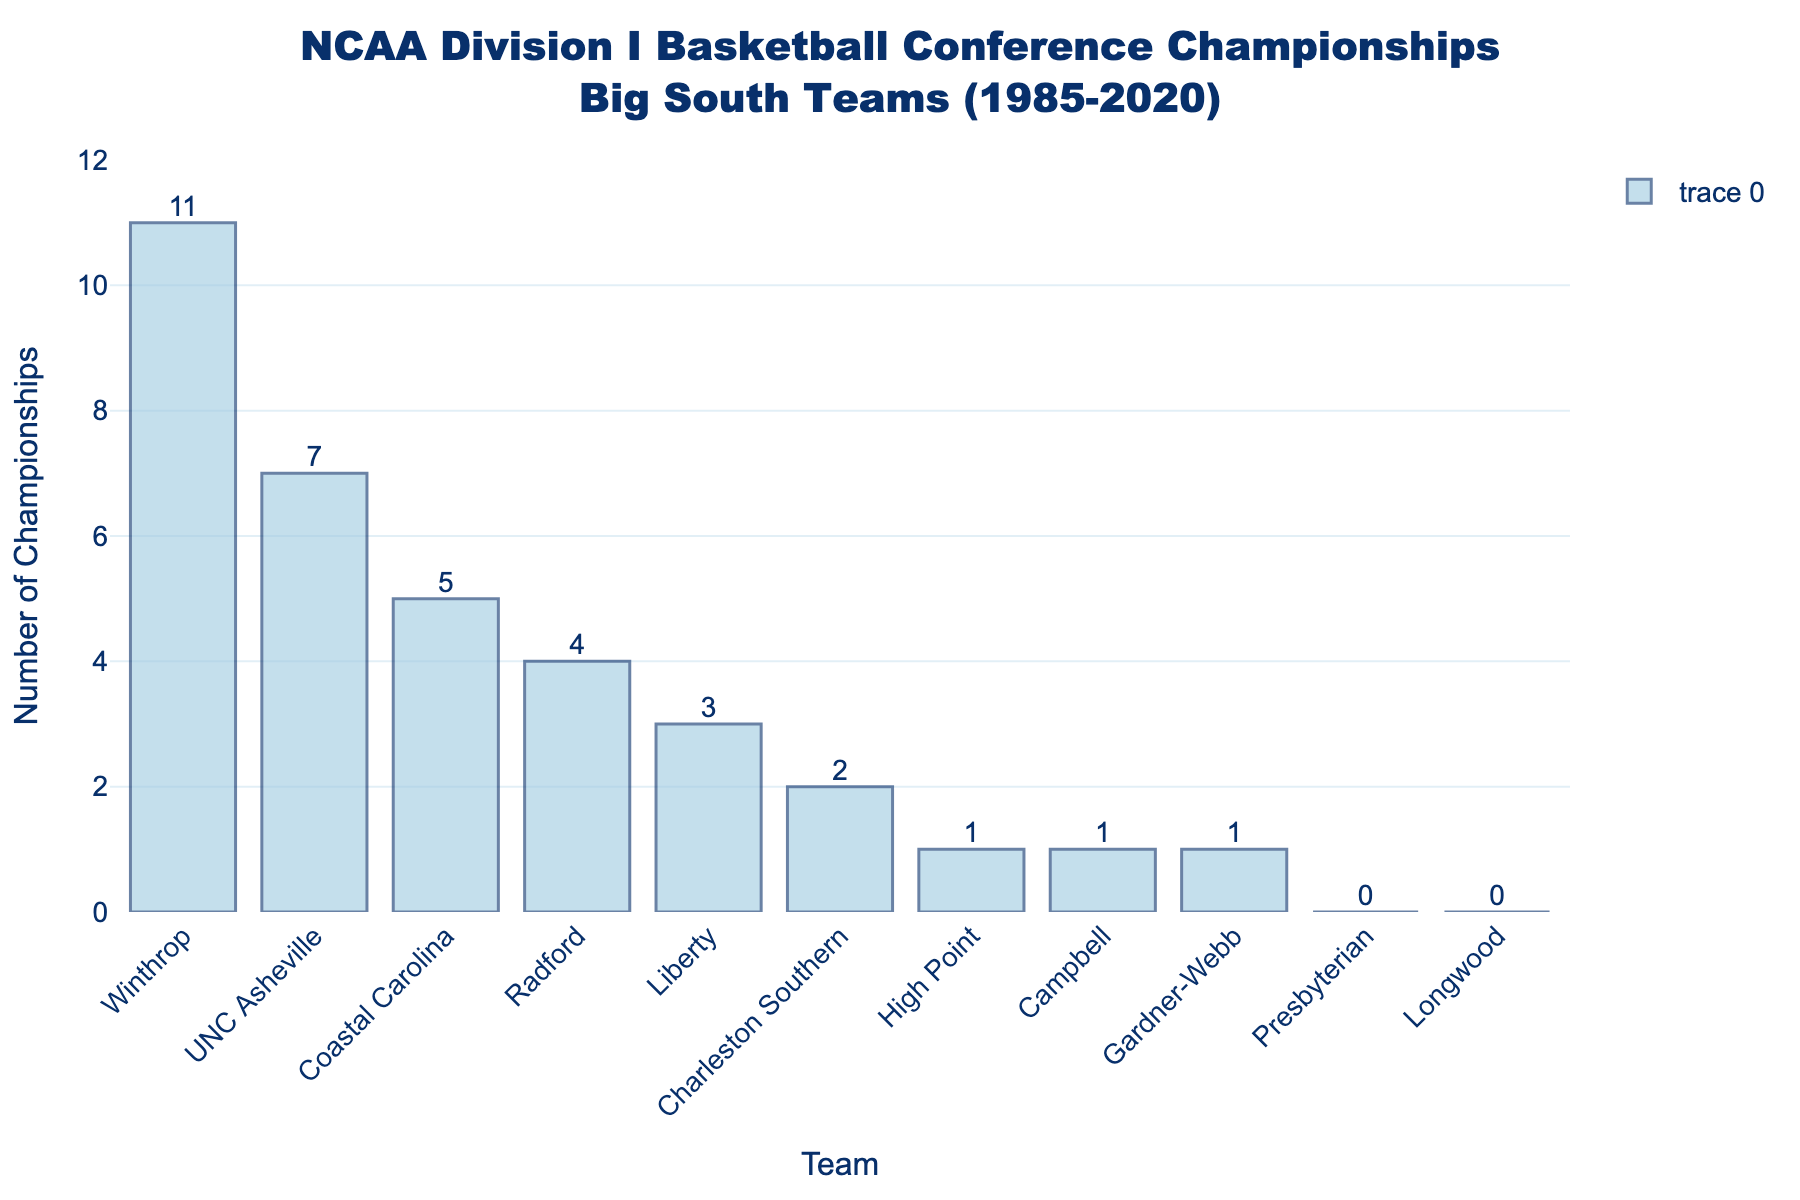What team has won the most championships? The bar representing Winthrop is the tallest in the chart, indicating they have the highest number of championships won. This is confirmed by the label on top of the bar showing 11 championships.
Answer: Winthrop How many teams have won exactly one championship? The bars representing High Point, Campbell, and Gardner-Webb each have a height corresponding to one championship.
Answer: 3 Which team has won more championships, Radford or Coastal Carolina? By comparing the heights of the bars for Radford and Coastal Carolina, it's clear Coastal Carolina's bar is taller, indicating more championships. Specifically, Coastal Carolina has 5 while Radford has 4.
Answer: Coastal Carolina What's the total number of championships won by all teams combined? By summing up all the numbers on top of the bars: 11 (Winthrop) + 7 (UNC Asheville) + 5 (Coastal Carolina) + 4 (Radford) + 3 (Liberty) + 2 (Charleston Southern) + 1 (High Point) + 1 (Campbell) + 1 (Gardner-Webb) + 0 (Presbyterian) + 0 (Longwood) = 34.
Answer: 34 How many more championships has Winthrop won compared to UNC Asheville? Winthrop has 11 championships and UNC Asheville has 7. The difference is 11 - 7 = 4.
Answer: 4 Which teams have never won a championship? The bars for Presbyterian and Longwood have a height of zero, indicating they have never won a championship.
Answer: Presbyterian, Longwood What is the average number of championships won per team? The total number of championships won by all teams is 34. There are 11 teams in total. The average is 34 / 11 ≈ 3.09.
Answer: 3.09 Which team's bar is halfway between the heights of Winthrop's bar and High Point's bar (in terms of number of championships)? Winthrop has 11 championships, and High Point has 1. Halfway between 11 and 1 is (11+1) / 2 = 6. Coastal Carolina's bar represents 5 championships, which is the closest to 6.
Answer: Coastal Carolina How many teams have won more than 3 championships? Winthrop (11), UNC Asheville (7), and Coastal Carolina (5) all have more than 3 championships. That's a total of 3 teams.
Answer: 3 